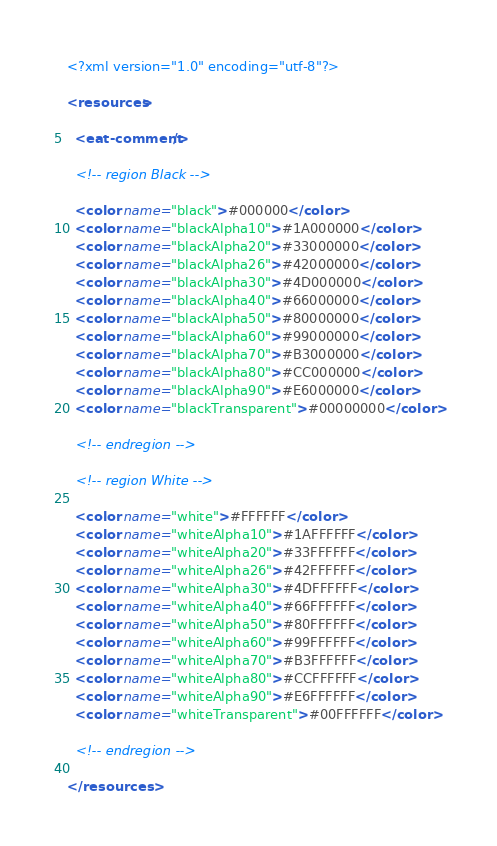Convert code to text. <code><loc_0><loc_0><loc_500><loc_500><_XML_><?xml version="1.0" encoding="utf-8"?>

<resources>

  <eat-comment/>

  <!-- region Black -->

  <color name="black">#000000</color>
  <color name="blackAlpha10">#1A000000</color>
  <color name="blackAlpha20">#33000000</color>
  <color name="blackAlpha26">#42000000</color>
  <color name="blackAlpha30">#4D000000</color>
  <color name="blackAlpha40">#66000000</color>
  <color name="blackAlpha50">#80000000</color>
  <color name="blackAlpha60">#99000000</color>
  <color name="blackAlpha70">#B3000000</color>
  <color name="blackAlpha80">#CC000000</color>
  <color name="blackAlpha90">#E6000000</color>
  <color name="blackTransparent">#00000000</color>

  <!-- endregion -->

  <!-- region White -->

  <color name="white">#FFFFFF</color>
  <color name="whiteAlpha10">#1AFFFFFF</color>
  <color name="whiteAlpha20">#33FFFFFF</color>
  <color name="whiteAlpha26">#42FFFFFF</color>
  <color name="whiteAlpha30">#4DFFFFFF</color>
  <color name="whiteAlpha40">#66FFFFFF</color>
  <color name="whiteAlpha50">#80FFFFFF</color>
  <color name="whiteAlpha60">#99FFFFFF</color>
  <color name="whiteAlpha70">#B3FFFFFF</color>
  <color name="whiteAlpha80">#CCFFFFFF</color>
  <color name="whiteAlpha90">#E6FFFFFF</color>
  <color name="whiteTransparent">#00FFFFFF</color>

  <!-- endregion -->

</resources>
</code> 